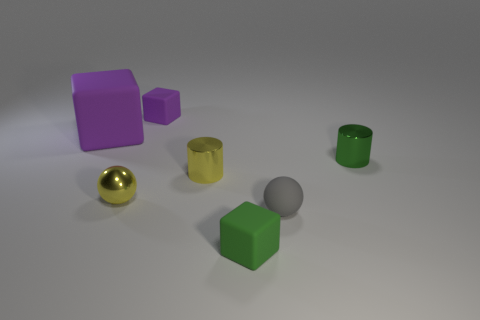Subtract all big purple cubes. How many cubes are left? 2 Subtract all green cylinders. How many purple blocks are left? 2 Add 1 tiny red cylinders. How many objects exist? 8 Subtract all yellow spheres. How many spheres are left? 1 Subtract all gray blocks. Subtract all green cylinders. How many blocks are left? 3 Add 5 green objects. How many green objects are left? 7 Add 5 large purple matte cubes. How many large purple matte cubes exist? 6 Subtract 0 red cylinders. How many objects are left? 7 Subtract all spheres. How many objects are left? 5 Subtract all small purple matte objects. Subtract all big purple blocks. How many objects are left? 5 